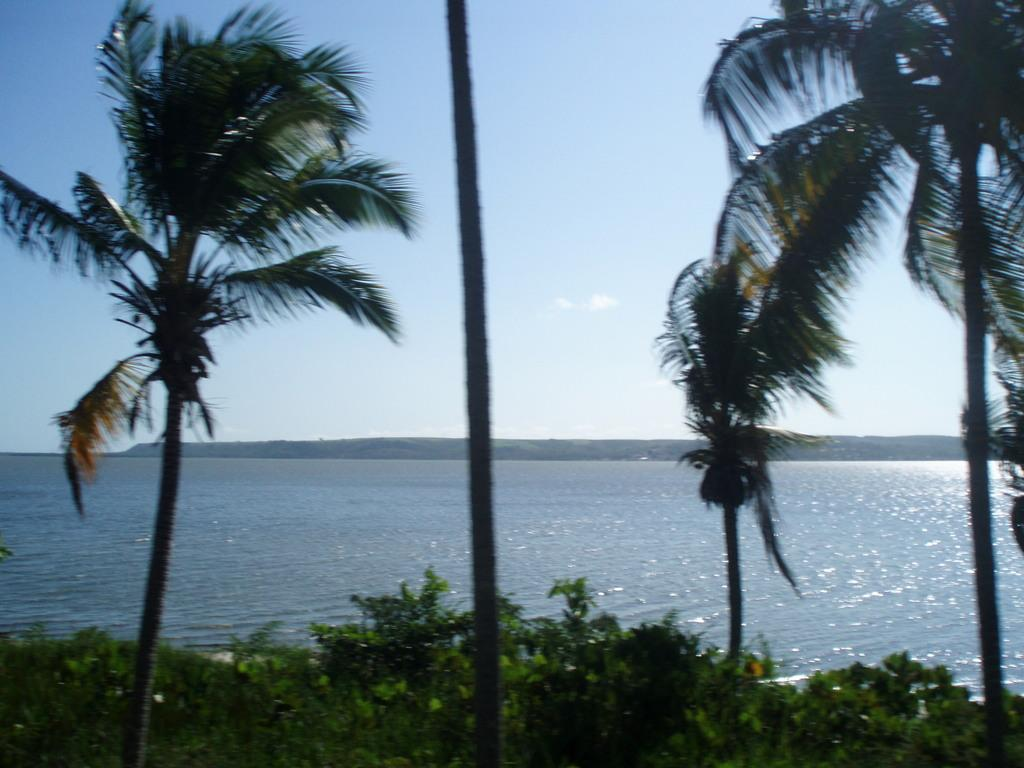What type of vegetation can be seen in the image? There are trees and plants in the image. What natural feature is visible in the background of the image? There is a river visible in the background of the image. What else can be seen in the background of the image? The sky is visible in the background of the image. Where is the stamp located in the image? There is no stamp present in the image. Can you describe the house in the image? There is no house present in the image. 